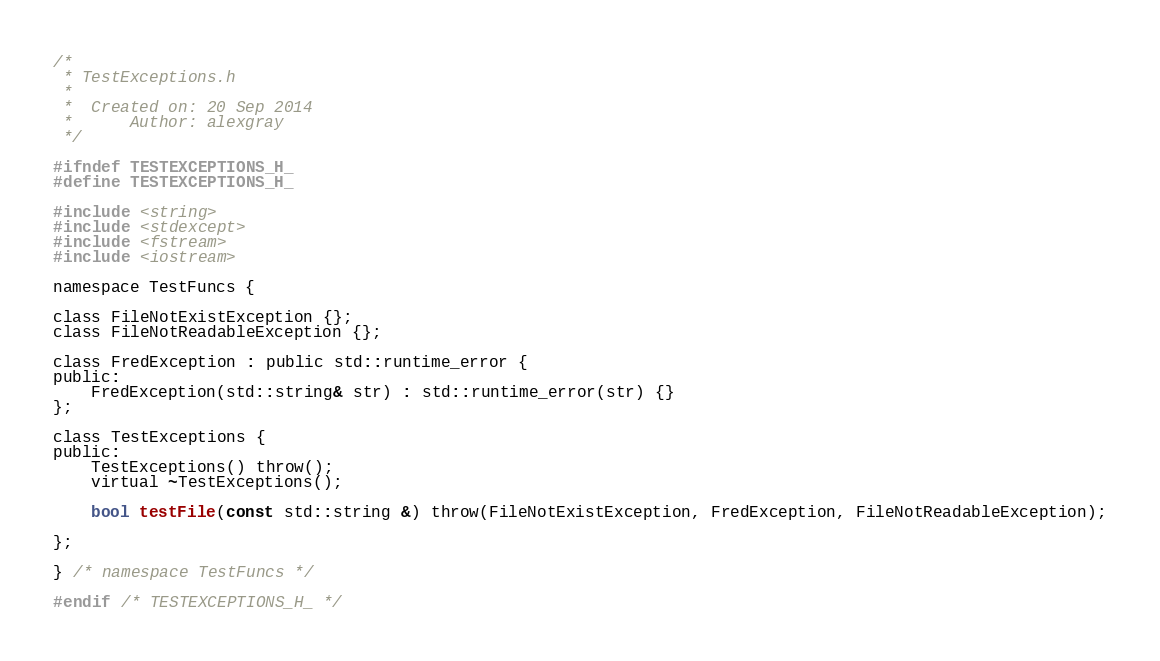<code> <loc_0><loc_0><loc_500><loc_500><_C_>/*
 * TestExceptions.h
 *
 *  Created on: 20 Sep 2014
 *      Author: alexgray
 */

#ifndef TESTEXCEPTIONS_H_
#define TESTEXCEPTIONS_H_

#include <string>
#include <stdexcept>
#include <fstream>
#include <iostream>

namespace TestFuncs {

class FileNotExistException {};
class FileNotReadableException {};

class FredException : public std::runtime_error {
public:
	FredException(std::string& str) : std::runtime_error(str) {}
};

class TestExceptions {
public:
	TestExceptions() throw();
	virtual ~TestExceptions();

	bool testFile(const std::string &) throw(FileNotExistException, FredException, FileNotReadableException);

};

} /* namespace TestFuncs */

#endif /* TESTEXCEPTIONS_H_ */
</code> 